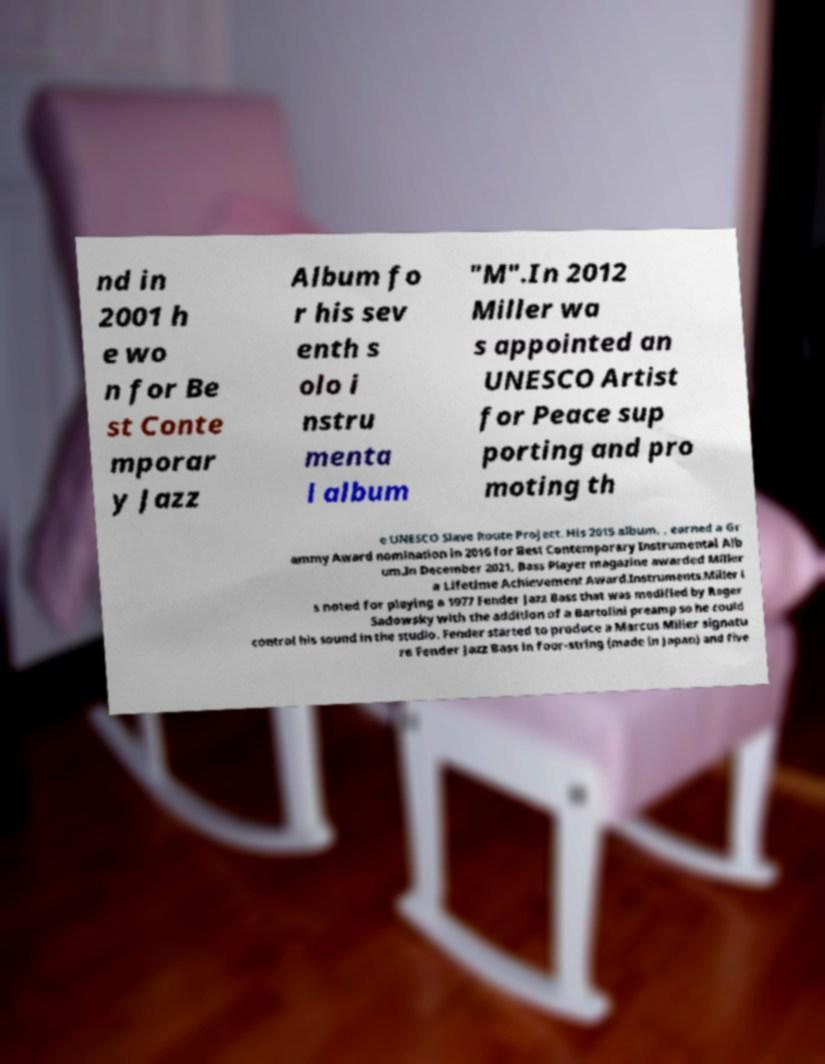What messages or text are displayed in this image? I need them in a readable, typed format. nd in 2001 h e wo n for Be st Conte mporar y Jazz Album fo r his sev enth s olo i nstru menta l album "M".In 2012 Miller wa s appointed an UNESCO Artist for Peace sup porting and pro moting th e UNESCO Slave Route Project. His 2015 album, , earned a Gr ammy Award nomination in 2016 for Best Contemporary Instrumental Alb um.In December 2021, Bass Player magazine awarded Miller a Lifetime Achievement Award.Instruments.Miller i s noted for playing a 1977 Fender Jazz Bass that was modified by Roger Sadowsky with the addition of a Bartolini preamp so he could control his sound in the studio. Fender started to produce a Marcus Miller signatu re Fender Jazz Bass in four-string (made in Japan) and five 